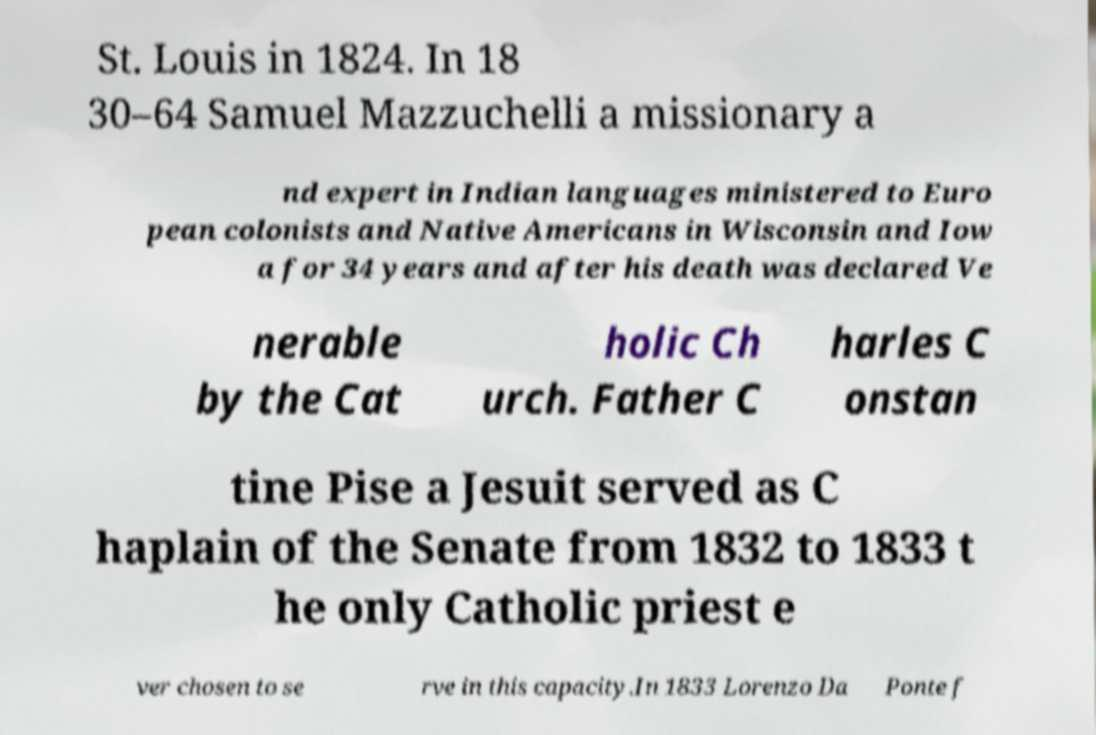Can you accurately transcribe the text from the provided image for me? St. Louis in 1824. In 18 30–64 Samuel Mazzuchelli a missionary a nd expert in Indian languages ministered to Euro pean colonists and Native Americans in Wisconsin and Iow a for 34 years and after his death was declared Ve nerable by the Cat holic Ch urch. Father C harles C onstan tine Pise a Jesuit served as C haplain of the Senate from 1832 to 1833 t he only Catholic priest e ver chosen to se rve in this capacity.In 1833 Lorenzo Da Ponte f 